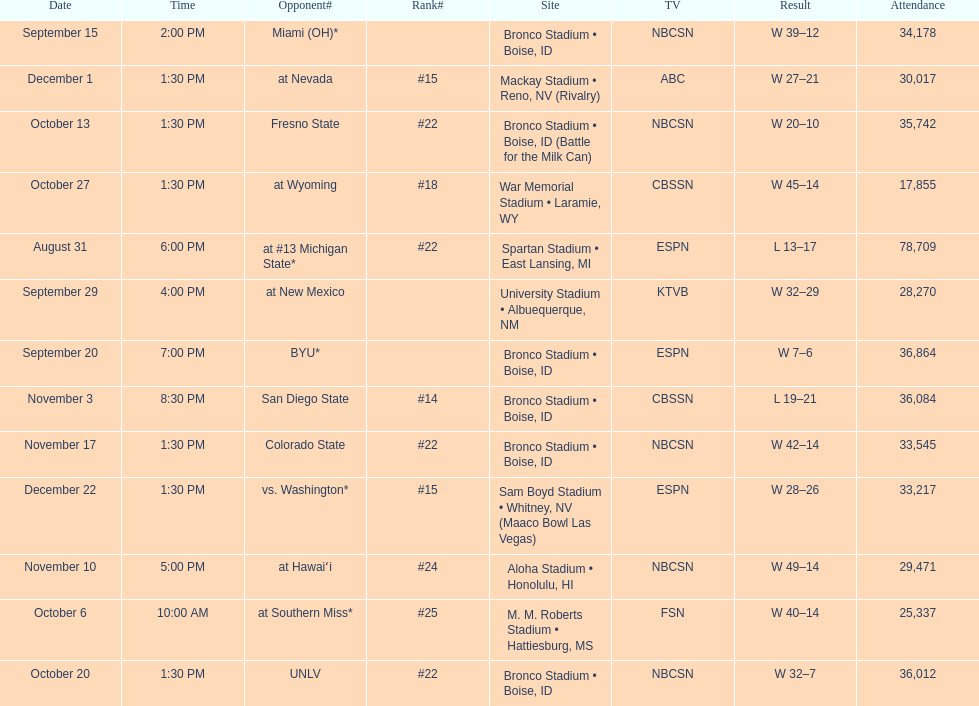What are the opponents to the  2012 boise state broncos football team? At #13 michigan state*, miami (oh)*, byu*, at new mexico, at southern miss*, fresno state, unlv, at wyoming, san diego state, at hawaiʻi, colorado state, at nevada, vs. washington*. Which is the highest ranked of the teams? San Diego State. 